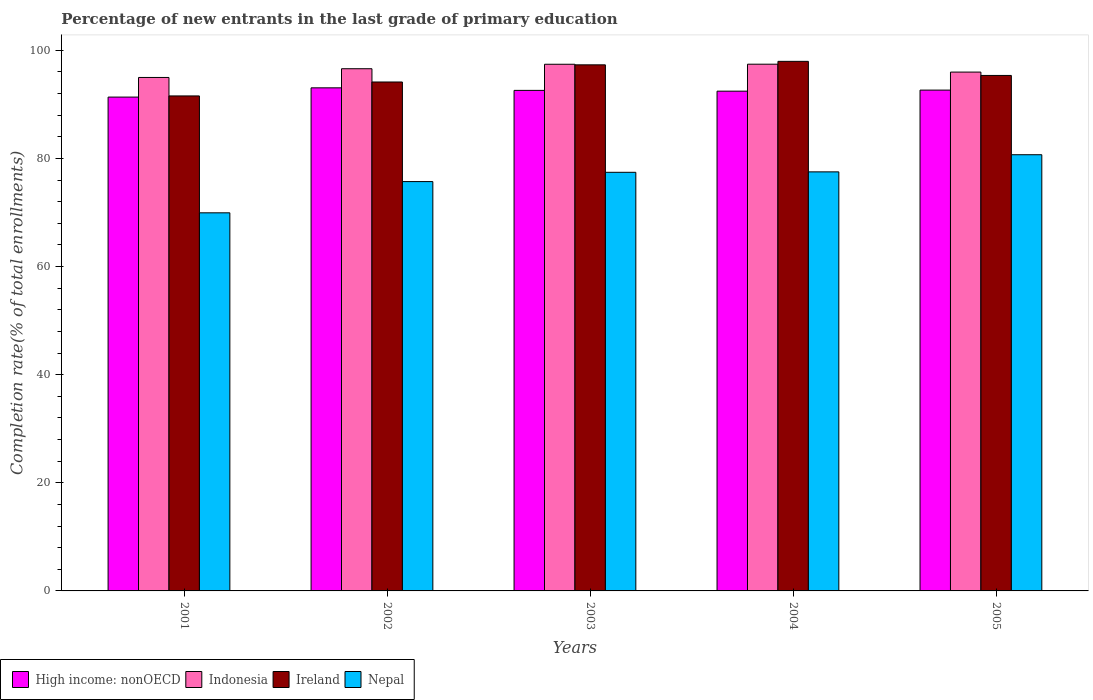How many different coloured bars are there?
Your answer should be very brief. 4. How many groups of bars are there?
Your answer should be compact. 5. Are the number of bars per tick equal to the number of legend labels?
Keep it short and to the point. Yes. Are the number of bars on each tick of the X-axis equal?
Offer a very short reply. Yes. How many bars are there on the 5th tick from the right?
Provide a short and direct response. 4. What is the label of the 3rd group of bars from the left?
Make the answer very short. 2003. In how many cases, is the number of bars for a given year not equal to the number of legend labels?
Your answer should be compact. 0. What is the percentage of new entrants in Nepal in 2002?
Give a very brief answer. 75.71. Across all years, what is the maximum percentage of new entrants in Nepal?
Offer a terse response. 80.68. Across all years, what is the minimum percentage of new entrants in Indonesia?
Make the answer very short. 94.97. In which year was the percentage of new entrants in Indonesia maximum?
Make the answer very short. 2004. What is the total percentage of new entrants in Ireland in the graph?
Provide a succinct answer. 476.27. What is the difference between the percentage of new entrants in Indonesia in 2003 and that in 2004?
Your answer should be very brief. -0.01. What is the difference between the percentage of new entrants in Ireland in 2003 and the percentage of new entrants in Indonesia in 2004?
Keep it short and to the point. -0.12. What is the average percentage of new entrants in High income: nonOECD per year?
Your answer should be compact. 92.4. In the year 2004, what is the difference between the percentage of new entrants in Ireland and percentage of new entrants in Indonesia?
Provide a short and direct response. 0.52. What is the ratio of the percentage of new entrants in Nepal in 2001 to that in 2003?
Give a very brief answer. 0.9. Is the difference between the percentage of new entrants in Ireland in 2003 and 2004 greater than the difference between the percentage of new entrants in Indonesia in 2003 and 2004?
Offer a terse response. No. What is the difference between the highest and the second highest percentage of new entrants in Nepal?
Your answer should be compact. 3.17. What is the difference between the highest and the lowest percentage of new entrants in Nepal?
Your answer should be compact. 10.75. Is it the case that in every year, the sum of the percentage of new entrants in High income: nonOECD and percentage of new entrants in Indonesia is greater than the sum of percentage of new entrants in Nepal and percentage of new entrants in Ireland?
Provide a short and direct response. No. What does the 1st bar from the left in 2001 represents?
Offer a terse response. High income: nonOECD. What does the 4th bar from the right in 2001 represents?
Offer a terse response. High income: nonOECD. Are all the bars in the graph horizontal?
Ensure brevity in your answer.  No. How many legend labels are there?
Provide a short and direct response. 4. How are the legend labels stacked?
Keep it short and to the point. Horizontal. What is the title of the graph?
Your answer should be very brief. Percentage of new entrants in the last grade of primary education. What is the label or title of the X-axis?
Provide a succinct answer. Years. What is the label or title of the Y-axis?
Offer a very short reply. Completion rate(% of total enrollments). What is the Completion rate(% of total enrollments) in High income: nonOECD in 2001?
Keep it short and to the point. 91.34. What is the Completion rate(% of total enrollments) of Indonesia in 2001?
Keep it short and to the point. 94.97. What is the Completion rate(% of total enrollments) in Ireland in 2001?
Provide a short and direct response. 91.55. What is the Completion rate(% of total enrollments) in Nepal in 2001?
Provide a succinct answer. 69.93. What is the Completion rate(% of total enrollments) in High income: nonOECD in 2002?
Offer a terse response. 93.05. What is the Completion rate(% of total enrollments) in Indonesia in 2002?
Your response must be concise. 96.58. What is the Completion rate(% of total enrollments) in Ireland in 2002?
Ensure brevity in your answer.  94.13. What is the Completion rate(% of total enrollments) of Nepal in 2002?
Your response must be concise. 75.71. What is the Completion rate(% of total enrollments) in High income: nonOECD in 2003?
Provide a succinct answer. 92.58. What is the Completion rate(% of total enrollments) of Indonesia in 2003?
Your answer should be very brief. 97.41. What is the Completion rate(% of total enrollments) in Ireland in 2003?
Your response must be concise. 97.3. What is the Completion rate(% of total enrollments) in Nepal in 2003?
Your response must be concise. 77.43. What is the Completion rate(% of total enrollments) in High income: nonOECD in 2004?
Offer a terse response. 92.43. What is the Completion rate(% of total enrollments) of Indonesia in 2004?
Your response must be concise. 97.42. What is the Completion rate(% of total enrollments) in Ireland in 2004?
Ensure brevity in your answer.  97.95. What is the Completion rate(% of total enrollments) of Nepal in 2004?
Make the answer very short. 77.51. What is the Completion rate(% of total enrollments) in High income: nonOECD in 2005?
Ensure brevity in your answer.  92.63. What is the Completion rate(% of total enrollments) in Indonesia in 2005?
Ensure brevity in your answer.  95.96. What is the Completion rate(% of total enrollments) of Ireland in 2005?
Ensure brevity in your answer.  95.34. What is the Completion rate(% of total enrollments) in Nepal in 2005?
Offer a terse response. 80.68. Across all years, what is the maximum Completion rate(% of total enrollments) of High income: nonOECD?
Make the answer very short. 93.05. Across all years, what is the maximum Completion rate(% of total enrollments) of Indonesia?
Keep it short and to the point. 97.42. Across all years, what is the maximum Completion rate(% of total enrollments) in Ireland?
Give a very brief answer. 97.95. Across all years, what is the maximum Completion rate(% of total enrollments) in Nepal?
Provide a short and direct response. 80.68. Across all years, what is the minimum Completion rate(% of total enrollments) in High income: nonOECD?
Your answer should be very brief. 91.34. Across all years, what is the minimum Completion rate(% of total enrollments) of Indonesia?
Your response must be concise. 94.97. Across all years, what is the minimum Completion rate(% of total enrollments) in Ireland?
Offer a very short reply. 91.55. Across all years, what is the minimum Completion rate(% of total enrollments) in Nepal?
Offer a terse response. 69.93. What is the total Completion rate(% of total enrollments) in High income: nonOECD in the graph?
Your answer should be very brief. 462.02. What is the total Completion rate(% of total enrollments) of Indonesia in the graph?
Your response must be concise. 482.34. What is the total Completion rate(% of total enrollments) of Ireland in the graph?
Give a very brief answer. 476.27. What is the total Completion rate(% of total enrollments) in Nepal in the graph?
Provide a succinct answer. 381.25. What is the difference between the Completion rate(% of total enrollments) in High income: nonOECD in 2001 and that in 2002?
Keep it short and to the point. -1.71. What is the difference between the Completion rate(% of total enrollments) of Indonesia in 2001 and that in 2002?
Keep it short and to the point. -1.62. What is the difference between the Completion rate(% of total enrollments) of Ireland in 2001 and that in 2002?
Provide a short and direct response. -2.58. What is the difference between the Completion rate(% of total enrollments) in Nepal in 2001 and that in 2002?
Your answer should be very brief. -5.78. What is the difference between the Completion rate(% of total enrollments) in High income: nonOECD in 2001 and that in 2003?
Provide a short and direct response. -1.24. What is the difference between the Completion rate(% of total enrollments) in Indonesia in 2001 and that in 2003?
Your response must be concise. -2.44. What is the difference between the Completion rate(% of total enrollments) in Ireland in 2001 and that in 2003?
Ensure brevity in your answer.  -5.75. What is the difference between the Completion rate(% of total enrollments) of Nepal in 2001 and that in 2003?
Provide a succinct answer. -7.49. What is the difference between the Completion rate(% of total enrollments) in High income: nonOECD in 2001 and that in 2004?
Make the answer very short. -1.1. What is the difference between the Completion rate(% of total enrollments) in Indonesia in 2001 and that in 2004?
Your response must be concise. -2.46. What is the difference between the Completion rate(% of total enrollments) in Ireland in 2001 and that in 2004?
Give a very brief answer. -6.39. What is the difference between the Completion rate(% of total enrollments) of Nepal in 2001 and that in 2004?
Your response must be concise. -7.58. What is the difference between the Completion rate(% of total enrollments) of High income: nonOECD in 2001 and that in 2005?
Your answer should be very brief. -1.29. What is the difference between the Completion rate(% of total enrollments) in Indonesia in 2001 and that in 2005?
Make the answer very short. -1. What is the difference between the Completion rate(% of total enrollments) in Ireland in 2001 and that in 2005?
Your answer should be very brief. -3.79. What is the difference between the Completion rate(% of total enrollments) of Nepal in 2001 and that in 2005?
Provide a short and direct response. -10.75. What is the difference between the Completion rate(% of total enrollments) in High income: nonOECD in 2002 and that in 2003?
Offer a terse response. 0.47. What is the difference between the Completion rate(% of total enrollments) in Indonesia in 2002 and that in 2003?
Your response must be concise. -0.83. What is the difference between the Completion rate(% of total enrollments) of Ireland in 2002 and that in 2003?
Provide a short and direct response. -3.17. What is the difference between the Completion rate(% of total enrollments) in Nepal in 2002 and that in 2003?
Provide a succinct answer. -1.72. What is the difference between the Completion rate(% of total enrollments) in High income: nonOECD in 2002 and that in 2004?
Keep it short and to the point. 0.61. What is the difference between the Completion rate(% of total enrollments) in Indonesia in 2002 and that in 2004?
Your response must be concise. -0.84. What is the difference between the Completion rate(% of total enrollments) of Ireland in 2002 and that in 2004?
Provide a short and direct response. -3.82. What is the difference between the Completion rate(% of total enrollments) in Nepal in 2002 and that in 2004?
Give a very brief answer. -1.8. What is the difference between the Completion rate(% of total enrollments) in High income: nonOECD in 2002 and that in 2005?
Your answer should be compact. 0.42. What is the difference between the Completion rate(% of total enrollments) of Indonesia in 2002 and that in 2005?
Offer a terse response. 0.62. What is the difference between the Completion rate(% of total enrollments) of Ireland in 2002 and that in 2005?
Make the answer very short. -1.21. What is the difference between the Completion rate(% of total enrollments) in Nepal in 2002 and that in 2005?
Offer a terse response. -4.97. What is the difference between the Completion rate(% of total enrollments) in High income: nonOECD in 2003 and that in 2004?
Offer a very short reply. 0.14. What is the difference between the Completion rate(% of total enrollments) of Indonesia in 2003 and that in 2004?
Give a very brief answer. -0.01. What is the difference between the Completion rate(% of total enrollments) in Ireland in 2003 and that in 2004?
Offer a terse response. -0.64. What is the difference between the Completion rate(% of total enrollments) in Nepal in 2003 and that in 2004?
Give a very brief answer. -0.08. What is the difference between the Completion rate(% of total enrollments) in High income: nonOECD in 2003 and that in 2005?
Provide a succinct answer. -0.05. What is the difference between the Completion rate(% of total enrollments) in Indonesia in 2003 and that in 2005?
Ensure brevity in your answer.  1.45. What is the difference between the Completion rate(% of total enrollments) in Ireland in 2003 and that in 2005?
Provide a short and direct response. 1.96. What is the difference between the Completion rate(% of total enrollments) of Nepal in 2003 and that in 2005?
Make the answer very short. -3.25. What is the difference between the Completion rate(% of total enrollments) in High income: nonOECD in 2004 and that in 2005?
Offer a very short reply. -0.19. What is the difference between the Completion rate(% of total enrollments) in Indonesia in 2004 and that in 2005?
Provide a succinct answer. 1.46. What is the difference between the Completion rate(% of total enrollments) of Ireland in 2004 and that in 2005?
Ensure brevity in your answer.  2.61. What is the difference between the Completion rate(% of total enrollments) of Nepal in 2004 and that in 2005?
Your answer should be compact. -3.17. What is the difference between the Completion rate(% of total enrollments) of High income: nonOECD in 2001 and the Completion rate(% of total enrollments) of Indonesia in 2002?
Your answer should be very brief. -5.25. What is the difference between the Completion rate(% of total enrollments) in High income: nonOECD in 2001 and the Completion rate(% of total enrollments) in Ireland in 2002?
Your answer should be compact. -2.79. What is the difference between the Completion rate(% of total enrollments) of High income: nonOECD in 2001 and the Completion rate(% of total enrollments) of Nepal in 2002?
Offer a terse response. 15.63. What is the difference between the Completion rate(% of total enrollments) in Indonesia in 2001 and the Completion rate(% of total enrollments) in Ireland in 2002?
Provide a short and direct response. 0.84. What is the difference between the Completion rate(% of total enrollments) in Indonesia in 2001 and the Completion rate(% of total enrollments) in Nepal in 2002?
Your answer should be very brief. 19.26. What is the difference between the Completion rate(% of total enrollments) in Ireland in 2001 and the Completion rate(% of total enrollments) in Nepal in 2002?
Make the answer very short. 15.84. What is the difference between the Completion rate(% of total enrollments) of High income: nonOECD in 2001 and the Completion rate(% of total enrollments) of Indonesia in 2003?
Your answer should be very brief. -6.07. What is the difference between the Completion rate(% of total enrollments) of High income: nonOECD in 2001 and the Completion rate(% of total enrollments) of Ireland in 2003?
Ensure brevity in your answer.  -5.96. What is the difference between the Completion rate(% of total enrollments) of High income: nonOECD in 2001 and the Completion rate(% of total enrollments) of Nepal in 2003?
Make the answer very short. 13.91. What is the difference between the Completion rate(% of total enrollments) in Indonesia in 2001 and the Completion rate(% of total enrollments) in Ireland in 2003?
Provide a short and direct response. -2.34. What is the difference between the Completion rate(% of total enrollments) in Indonesia in 2001 and the Completion rate(% of total enrollments) in Nepal in 2003?
Offer a very short reply. 17.54. What is the difference between the Completion rate(% of total enrollments) in Ireland in 2001 and the Completion rate(% of total enrollments) in Nepal in 2003?
Keep it short and to the point. 14.13. What is the difference between the Completion rate(% of total enrollments) of High income: nonOECD in 2001 and the Completion rate(% of total enrollments) of Indonesia in 2004?
Provide a succinct answer. -6.08. What is the difference between the Completion rate(% of total enrollments) in High income: nonOECD in 2001 and the Completion rate(% of total enrollments) in Ireland in 2004?
Provide a succinct answer. -6.61. What is the difference between the Completion rate(% of total enrollments) of High income: nonOECD in 2001 and the Completion rate(% of total enrollments) of Nepal in 2004?
Provide a short and direct response. 13.83. What is the difference between the Completion rate(% of total enrollments) in Indonesia in 2001 and the Completion rate(% of total enrollments) in Ireland in 2004?
Provide a short and direct response. -2.98. What is the difference between the Completion rate(% of total enrollments) in Indonesia in 2001 and the Completion rate(% of total enrollments) in Nepal in 2004?
Your answer should be very brief. 17.46. What is the difference between the Completion rate(% of total enrollments) in Ireland in 2001 and the Completion rate(% of total enrollments) in Nepal in 2004?
Ensure brevity in your answer.  14.04. What is the difference between the Completion rate(% of total enrollments) in High income: nonOECD in 2001 and the Completion rate(% of total enrollments) in Indonesia in 2005?
Make the answer very short. -4.62. What is the difference between the Completion rate(% of total enrollments) in High income: nonOECD in 2001 and the Completion rate(% of total enrollments) in Ireland in 2005?
Your answer should be compact. -4. What is the difference between the Completion rate(% of total enrollments) in High income: nonOECD in 2001 and the Completion rate(% of total enrollments) in Nepal in 2005?
Give a very brief answer. 10.66. What is the difference between the Completion rate(% of total enrollments) in Indonesia in 2001 and the Completion rate(% of total enrollments) in Ireland in 2005?
Provide a short and direct response. -0.37. What is the difference between the Completion rate(% of total enrollments) of Indonesia in 2001 and the Completion rate(% of total enrollments) of Nepal in 2005?
Your response must be concise. 14.29. What is the difference between the Completion rate(% of total enrollments) in Ireland in 2001 and the Completion rate(% of total enrollments) in Nepal in 2005?
Your answer should be very brief. 10.87. What is the difference between the Completion rate(% of total enrollments) of High income: nonOECD in 2002 and the Completion rate(% of total enrollments) of Indonesia in 2003?
Provide a succinct answer. -4.36. What is the difference between the Completion rate(% of total enrollments) of High income: nonOECD in 2002 and the Completion rate(% of total enrollments) of Ireland in 2003?
Offer a very short reply. -4.25. What is the difference between the Completion rate(% of total enrollments) of High income: nonOECD in 2002 and the Completion rate(% of total enrollments) of Nepal in 2003?
Your response must be concise. 15.62. What is the difference between the Completion rate(% of total enrollments) of Indonesia in 2002 and the Completion rate(% of total enrollments) of Ireland in 2003?
Offer a terse response. -0.72. What is the difference between the Completion rate(% of total enrollments) in Indonesia in 2002 and the Completion rate(% of total enrollments) in Nepal in 2003?
Give a very brief answer. 19.16. What is the difference between the Completion rate(% of total enrollments) in Ireland in 2002 and the Completion rate(% of total enrollments) in Nepal in 2003?
Keep it short and to the point. 16.7. What is the difference between the Completion rate(% of total enrollments) of High income: nonOECD in 2002 and the Completion rate(% of total enrollments) of Indonesia in 2004?
Ensure brevity in your answer.  -4.37. What is the difference between the Completion rate(% of total enrollments) in High income: nonOECD in 2002 and the Completion rate(% of total enrollments) in Ireland in 2004?
Give a very brief answer. -4.9. What is the difference between the Completion rate(% of total enrollments) in High income: nonOECD in 2002 and the Completion rate(% of total enrollments) in Nepal in 2004?
Your response must be concise. 15.54. What is the difference between the Completion rate(% of total enrollments) in Indonesia in 2002 and the Completion rate(% of total enrollments) in Ireland in 2004?
Your response must be concise. -1.36. What is the difference between the Completion rate(% of total enrollments) in Indonesia in 2002 and the Completion rate(% of total enrollments) in Nepal in 2004?
Provide a succinct answer. 19.08. What is the difference between the Completion rate(% of total enrollments) in Ireland in 2002 and the Completion rate(% of total enrollments) in Nepal in 2004?
Ensure brevity in your answer.  16.62. What is the difference between the Completion rate(% of total enrollments) of High income: nonOECD in 2002 and the Completion rate(% of total enrollments) of Indonesia in 2005?
Keep it short and to the point. -2.91. What is the difference between the Completion rate(% of total enrollments) in High income: nonOECD in 2002 and the Completion rate(% of total enrollments) in Ireland in 2005?
Your response must be concise. -2.29. What is the difference between the Completion rate(% of total enrollments) in High income: nonOECD in 2002 and the Completion rate(% of total enrollments) in Nepal in 2005?
Offer a very short reply. 12.37. What is the difference between the Completion rate(% of total enrollments) of Indonesia in 2002 and the Completion rate(% of total enrollments) of Ireland in 2005?
Your answer should be very brief. 1.24. What is the difference between the Completion rate(% of total enrollments) of Indonesia in 2002 and the Completion rate(% of total enrollments) of Nepal in 2005?
Provide a short and direct response. 15.91. What is the difference between the Completion rate(% of total enrollments) in Ireland in 2002 and the Completion rate(% of total enrollments) in Nepal in 2005?
Provide a succinct answer. 13.45. What is the difference between the Completion rate(% of total enrollments) in High income: nonOECD in 2003 and the Completion rate(% of total enrollments) in Indonesia in 2004?
Ensure brevity in your answer.  -4.84. What is the difference between the Completion rate(% of total enrollments) of High income: nonOECD in 2003 and the Completion rate(% of total enrollments) of Ireland in 2004?
Provide a short and direct response. -5.37. What is the difference between the Completion rate(% of total enrollments) of High income: nonOECD in 2003 and the Completion rate(% of total enrollments) of Nepal in 2004?
Your answer should be very brief. 15.07. What is the difference between the Completion rate(% of total enrollments) in Indonesia in 2003 and the Completion rate(% of total enrollments) in Ireland in 2004?
Your response must be concise. -0.54. What is the difference between the Completion rate(% of total enrollments) in Indonesia in 2003 and the Completion rate(% of total enrollments) in Nepal in 2004?
Your response must be concise. 19.9. What is the difference between the Completion rate(% of total enrollments) of Ireland in 2003 and the Completion rate(% of total enrollments) of Nepal in 2004?
Offer a very short reply. 19.8. What is the difference between the Completion rate(% of total enrollments) of High income: nonOECD in 2003 and the Completion rate(% of total enrollments) of Indonesia in 2005?
Make the answer very short. -3.39. What is the difference between the Completion rate(% of total enrollments) of High income: nonOECD in 2003 and the Completion rate(% of total enrollments) of Ireland in 2005?
Ensure brevity in your answer.  -2.76. What is the difference between the Completion rate(% of total enrollments) in High income: nonOECD in 2003 and the Completion rate(% of total enrollments) in Nepal in 2005?
Keep it short and to the point. 11.9. What is the difference between the Completion rate(% of total enrollments) of Indonesia in 2003 and the Completion rate(% of total enrollments) of Ireland in 2005?
Give a very brief answer. 2.07. What is the difference between the Completion rate(% of total enrollments) in Indonesia in 2003 and the Completion rate(% of total enrollments) in Nepal in 2005?
Provide a short and direct response. 16.73. What is the difference between the Completion rate(% of total enrollments) in Ireland in 2003 and the Completion rate(% of total enrollments) in Nepal in 2005?
Your answer should be very brief. 16.63. What is the difference between the Completion rate(% of total enrollments) in High income: nonOECD in 2004 and the Completion rate(% of total enrollments) in Indonesia in 2005?
Give a very brief answer. -3.53. What is the difference between the Completion rate(% of total enrollments) of High income: nonOECD in 2004 and the Completion rate(% of total enrollments) of Ireland in 2005?
Offer a terse response. -2.91. What is the difference between the Completion rate(% of total enrollments) in High income: nonOECD in 2004 and the Completion rate(% of total enrollments) in Nepal in 2005?
Your answer should be compact. 11.76. What is the difference between the Completion rate(% of total enrollments) in Indonesia in 2004 and the Completion rate(% of total enrollments) in Ireland in 2005?
Your answer should be compact. 2.08. What is the difference between the Completion rate(% of total enrollments) of Indonesia in 2004 and the Completion rate(% of total enrollments) of Nepal in 2005?
Give a very brief answer. 16.75. What is the difference between the Completion rate(% of total enrollments) of Ireland in 2004 and the Completion rate(% of total enrollments) of Nepal in 2005?
Provide a succinct answer. 17.27. What is the average Completion rate(% of total enrollments) in High income: nonOECD per year?
Give a very brief answer. 92.4. What is the average Completion rate(% of total enrollments) in Indonesia per year?
Your response must be concise. 96.47. What is the average Completion rate(% of total enrollments) in Ireland per year?
Keep it short and to the point. 95.25. What is the average Completion rate(% of total enrollments) of Nepal per year?
Your response must be concise. 76.25. In the year 2001, what is the difference between the Completion rate(% of total enrollments) in High income: nonOECD and Completion rate(% of total enrollments) in Indonesia?
Ensure brevity in your answer.  -3.63. In the year 2001, what is the difference between the Completion rate(% of total enrollments) in High income: nonOECD and Completion rate(% of total enrollments) in Ireland?
Keep it short and to the point. -0.21. In the year 2001, what is the difference between the Completion rate(% of total enrollments) of High income: nonOECD and Completion rate(% of total enrollments) of Nepal?
Your answer should be compact. 21.41. In the year 2001, what is the difference between the Completion rate(% of total enrollments) in Indonesia and Completion rate(% of total enrollments) in Ireland?
Keep it short and to the point. 3.41. In the year 2001, what is the difference between the Completion rate(% of total enrollments) in Indonesia and Completion rate(% of total enrollments) in Nepal?
Your answer should be very brief. 25.04. In the year 2001, what is the difference between the Completion rate(% of total enrollments) in Ireland and Completion rate(% of total enrollments) in Nepal?
Offer a very short reply. 21.62. In the year 2002, what is the difference between the Completion rate(% of total enrollments) in High income: nonOECD and Completion rate(% of total enrollments) in Indonesia?
Offer a very short reply. -3.53. In the year 2002, what is the difference between the Completion rate(% of total enrollments) in High income: nonOECD and Completion rate(% of total enrollments) in Ireland?
Offer a terse response. -1.08. In the year 2002, what is the difference between the Completion rate(% of total enrollments) of High income: nonOECD and Completion rate(% of total enrollments) of Nepal?
Keep it short and to the point. 17.34. In the year 2002, what is the difference between the Completion rate(% of total enrollments) in Indonesia and Completion rate(% of total enrollments) in Ireland?
Provide a succinct answer. 2.45. In the year 2002, what is the difference between the Completion rate(% of total enrollments) in Indonesia and Completion rate(% of total enrollments) in Nepal?
Ensure brevity in your answer.  20.87. In the year 2002, what is the difference between the Completion rate(% of total enrollments) in Ireland and Completion rate(% of total enrollments) in Nepal?
Your response must be concise. 18.42. In the year 2003, what is the difference between the Completion rate(% of total enrollments) in High income: nonOECD and Completion rate(% of total enrollments) in Indonesia?
Offer a very short reply. -4.83. In the year 2003, what is the difference between the Completion rate(% of total enrollments) of High income: nonOECD and Completion rate(% of total enrollments) of Ireland?
Your answer should be compact. -4.73. In the year 2003, what is the difference between the Completion rate(% of total enrollments) of High income: nonOECD and Completion rate(% of total enrollments) of Nepal?
Provide a short and direct response. 15.15. In the year 2003, what is the difference between the Completion rate(% of total enrollments) in Indonesia and Completion rate(% of total enrollments) in Ireland?
Your answer should be very brief. 0.11. In the year 2003, what is the difference between the Completion rate(% of total enrollments) of Indonesia and Completion rate(% of total enrollments) of Nepal?
Your answer should be very brief. 19.98. In the year 2003, what is the difference between the Completion rate(% of total enrollments) of Ireland and Completion rate(% of total enrollments) of Nepal?
Offer a very short reply. 19.88. In the year 2004, what is the difference between the Completion rate(% of total enrollments) of High income: nonOECD and Completion rate(% of total enrollments) of Indonesia?
Your response must be concise. -4.99. In the year 2004, what is the difference between the Completion rate(% of total enrollments) in High income: nonOECD and Completion rate(% of total enrollments) in Ireland?
Ensure brevity in your answer.  -5.51. In the year 2004, what is the difference between the Completion rate(% of total enrollments) of High income: nonOECD and Completion rate(% of total enrollments) of Nepal?
Give a very brief answer. 14.93. In the year 2004, what is the difference between the Completion rate(% of total enrollments) in Indonesia and Completion rate(% of total enrollments) in Ireland?
Your answer should be very brief. -0.52. In the year 2004, what is the difference between the Completion rate(% of total enrollments) of Indonesia and Completion rate(% of total enrollments) of Nepal?
Give a very brief answer. 19.91. In the year 2004, what is the difference between the Completion rate(% of total enrollments) of Ireland and Completion rate(% of total enrollments) of Nepal?
Your answer should be compact. 20.44. In the year 2005, what is the difference between the Completion rate(% of total enrollments) in High income: nonOECD and Completion rate(% of total enrollments) in Indonesia?
Offer a very short reply. -3.33. In the year 2005, what is the difference between the Completion rate(% of total enrollments) of High income: nonOECD and Completion rate(% of total enrollments) of Ireland?
Your answer should be very brief. -2.71. In the year 2005, what is the difference between the Completion rate(% of total enrollments) of High income: nonOECD and Completion rate(% of total enrollments) of Nepal?
Your answer should be compact. 11.95. In the year 2005, what is the difference between the Completion rate(% of total enrollments) of Indonesia and Completion rate(% of total enrollments) of Ireland?
Ensure brevity in your answer.  0.62. In the year 2005, what is the difference between the Completion rate(% of total enrollments) in Indonesia and Completion rate(% of total enrollments) in Nepal?
Make the answer very short. 15.29. In the year 2005, what is the difference between the Completion rate(% of total enrollments) of Ireland and Completion rate(% of total enrollments) of Nepal?
Your response must be concise. 14.66. What is the ratio of the Completion rate(% of total enrollments) of High income: nonOECD in 2001 to that in 2002?
Provide a succinct answer. 0.98. What is the ratio of the Completion rate(% of total enrollments) of Indonesia in 2001 to that in 2002?
Give a very brief answer. 0.98. What is the ratio of the Completion rate(% of total enrollments) of Ireland in 2001 to that in 2002?
Provide a succinct answer. 0.97. What is the ratio of the Completion rate(% of total enrollments) of Nepal in 2001 to that in 2002?
Ensure brevity in your answer.  0.92. What is the ratio of the Completion rate(% of total enrollments) in High income: nonOECD in 2001 to that in 2003?
Give a very brief answer. 0.99. What is the ratio of the Completion rate(% of total enrollments) in Indonesia in 2001 to that in 2003?
Make the answer very short. 0.97. What is the ratio of the Completion rate(% of total enrollments) of Ireland in 2001 to that in 2003?
Offer a terse response. 0.94. What is the ratio of the Completion rate(% of total enrollments) in Nepal in 2001 to that in 2003?
Provide a short and direct response. 0.9. What is the ratio of the Completion rate(% of total enrollments) in Indonesia in 2001 to that in 2004?
Keep it short and to the point. 0.97. What is the ratio of the Completion rate(% of total enrollments) of Ireland in 2001 to that in 2004?
Provide a short and direct response. 0.93. What is the ratio of the Completion rate(% of total enrollments) in Nepal in 2001 to that in 2004?
Give a very brief answer. 0.9. What is the ratio of the Completion rate(% of total enrollments) in High income: nonOECD in 2001 to that in 2005?
Offer a terse response. 0.99. What is the ratio of the Completion rate(% of total enrollments) in Ireland in 2001 to that in 2005?
Provide a succinct answer. 0.96. What is the ratio of the Completion rate(% of total enrollments) in Nepal in 2001 to that in 2005?
Ensure brevity in your answer.  0.87. What is the ratio of the Completion rate(% of total enrollments) in Indonesia in 2002 to that in 2003?
Keep it short and to the point. 0.99. What is the ratio of the Completion rate(% of total enrollments) of Ireland in 2002 to that in 2003?
Give a very brief answer. 0.97. What is the ratio of the Completion rate(% of total enrollments) of Nepal in 2002 to that in 2003?
Your response must be concise. 0.98. What is the ratio of the Completion rate(% of total enrollments) in High income: nonOECD in 2002 to that in 2004?
Give a very brief answer. 1.01. What is the ratio of the Completion rate(% of total enrollments) in Ireland in 2002 to that in 2004?
Give a very brief answer. 0.96. What is the ratio of the Completion rate(% of total enrollments) in Nepal in 2002 to that in 2004?
Make the answer very short. 0.98. What is the ratio of the Completion rate(% of total enrollments) of Ireland in 2002 to that in 2005?
Your answer should be compact. 0.99. What is the ratio of the Completion rate(% of total enrollments) of Nepal in 2002 to that in 2005?
Your answer should be very brief. 0.94. What is the ratio of the Completion rate(% of total enrollments) in High income: nonOECD in 2003 to that in 2004?
Your answer should be compact. 1. What is the ratio of the Completion rate(% of total enrollments) in Ireland in 2003 to that in 2004?
Your response must be concise. 0.99. What is the ratio of the Completion rate(% of total enrollments) in Nepal in 2003 to that in 2004?
Make the answer very short. 1. What is the ratio of the Completion rate(% of total enrollments) in Indonesia in 2003 to that in 2005?
Keep it short and to the point. 1.02. What is the ratio of the Completion rate(% of total enrollments) of Ireland in 2003 to that in 2005?
Make the answer very short. 1.02. What is the ratio of the Completion rate(% of total enrollments) of Nepal in 2003 to that in 2005?
Provide a short and direct response. 0.96. What is the ratio of the Completion rate(% of total enrollments) in Indonesia in 2004 to that in 2005?
Make the answer very short. 1.02. What is the ratio of the Completion rate(% of total enrollments) of Ireland in 2004 to that in 2005?
Keep it short and to the point. 1.03. What is the ratio of the Completion rate(% of total enrollments) of Nepal in 2004 to that in 2005?
Offer a very short reply. 0.96. What is the difference between the highest and the second highest Completion rate(% of total enrollments) of High income: nonOECD?
Offer a terse response. 0.42. What is the difference between the highest and the second highest Completion rate(% of total enrollments) in Indonesia?
Give a very brief answer. 0.01. What is the difference between the highest and the second highest Completion rate(% of total enrollments) of Ireland?
Give a very brief answer. 0.64. What is the difference between the highest and the second highest Completion rate(% of total enrollments) in Nepal?
Ensure brevity in your answer.  3.17. What is the difference between the highest and the lowest Completion rate(% of total enrollments) of High income: nonOECD?
Provide a short and direct response. 1.71. What is the difference between the highest and the lowest Completion rate(% of total enrollments) in Indonesia?
Give a very brief answer. 2.46. What is the difference between the highest and the lowest Completion rate(% of total enrollments) in Ireland?
Make the answer very short. 6.39. What is the difference between the highest and the lowest Completion rate(% of total enrollments) of Nepal?
Make the answer very short. 10.75. 